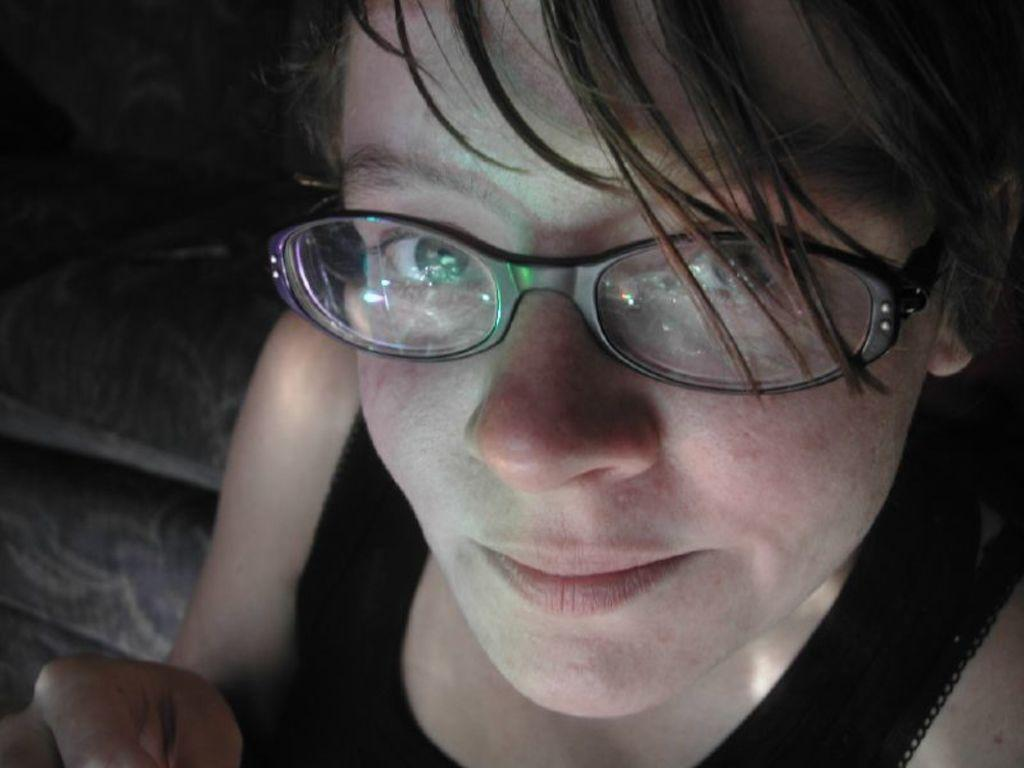What is the main subject of the image? There is a person in the image. What is the person wearing? The person is wearing a black dress and spectacles. What can be observed about the background of the image? The background of the image is dark. What type of copper object is being used by the laborer in the middle of the image? There is no laborer or copper object present in the image. 